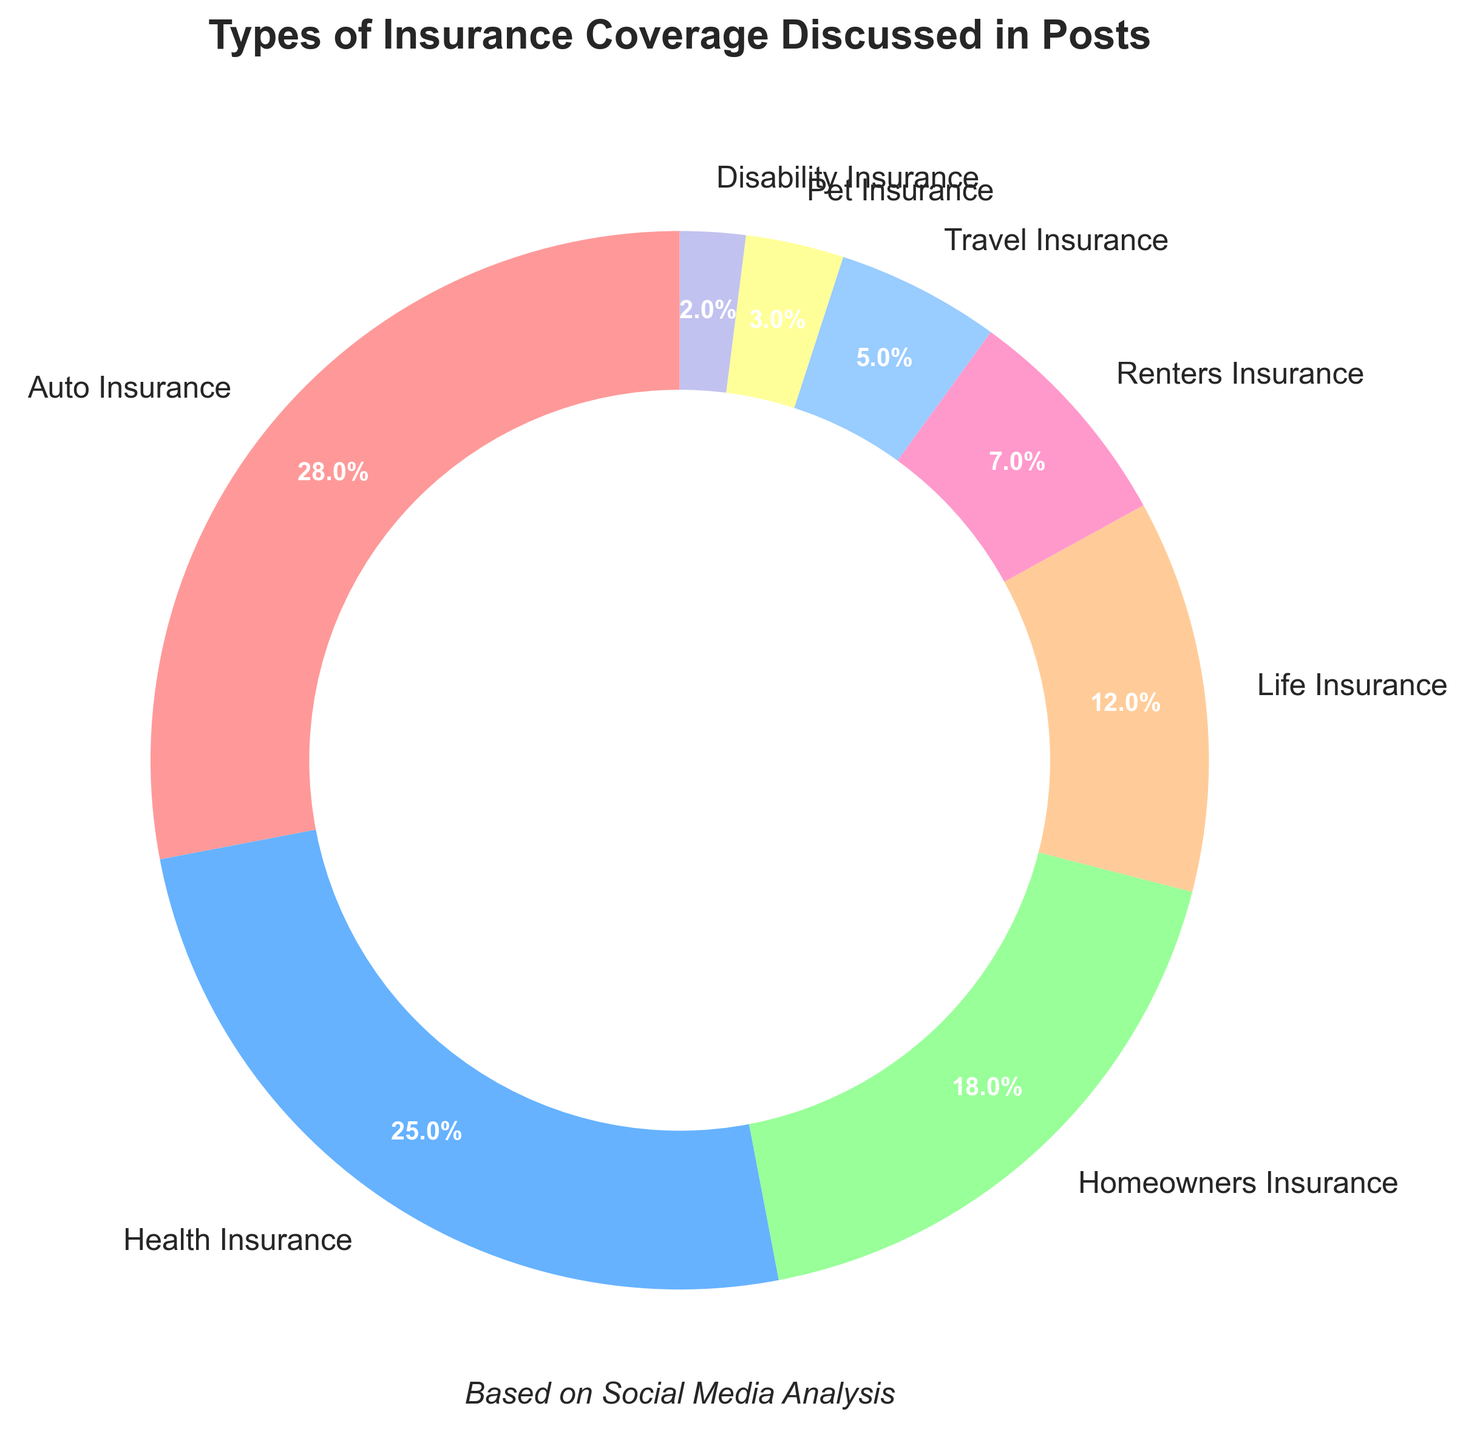What percentage of posts discuss Auto Insurance and Health Insurance combined? Add the percentage of Auto Insurance (28%) to the percentage of Health Insurance (25%). The combined percentage is 28% + 25% = 53%.
Answer: 53% Which type of insurance coverage is discussed the least frequently? Pet Insurance and Disability Insurance have the lowest percentages according to the chart, with Disability Insurance being the lowest at 2%.
Answer: Disability Insurance Are homeowners and renters combined more frequently discussed than life insurance alone? Add the percentages of homeowners (18%) and renters (7%) insurance and compare the sum to the percentage of life insurance (12%). The combined percentage is 18% + 7% = 25% which is greater than 12%.
Answer: Yes What is the difference in percentage between the most discussed insurance type and the least discussed insurance type? Subtract the percentage of Disability Insurance (2%) from the percentage of Auto Insurance (28%). The difference is 28% - 2% = 26%.
Answer: 26% Which types of insurance are discussed more frequently: Health and Homeowners Insurance combined, or Auto Insurance alone? Add the percentages of Health Insurance (25%) and Homeowners Insurance (18%) and compare to the percentage of Auto Insurance (28%). The combined percentage is 25% + 18% = 43%, which is greater than 28%.
Answer: Health and Homeowners Insurance combined By what percentage is Travel Insurance less frequently discussed than Homeowners Insurance? Subtract the percentage of Travel Insurance (5%) from the percentage of Homeowners Insurance (18%). The difference is 18% - 5% = 13%.
Answer: 13% How many types of insurance have a discussion frequency greater than or equal to 10%? Identify the types of insurance with percentages 10% or higher: Auto Insurance (28%), Health Insurance (25%), Homeowners Insurance (18%), and Life Insurance (12%). There are 4 types in total.
Answer: 4 Which type of insurance has a higher discussion frequency: Renters or Travel? Compare the percentages for Renters Insurance (7%) and Travel Insurance (5%). Renters Insurance has a higher frequency.
Answer: Renters Insurance What is the average discussion frequency of Auto, Health, and Life Insurance? Add the percentages of Auto (28%), Health (25%), and Life (12%) Insurance and divide by 3. The sum is 28% + 25% + 12% = 65%, so the average is 65% / 3 ≈ 21.67%.
Answer: 21.67% Which two insurance types together make up 33% of the discussions? Identify the pair of percentages that sum to 33%: Homeowners Insurance (18%) and Renters Insurance (7%) sum up to 18% + 7% = 25%; Homeowners Insurance (18%) and Travel Insurance (5%) sum up to 18% + 5% = 23%; Health Insurance (25%) and Disability Insurance (2%) sum up to 25% + 2% = 27%; Auto Insurance (28%) and Pet Insurance (3%) sum up to 28% + 3% = 31%; Auto Insurance (28%) and Disability Insurance (2%) sum up to 28% + 2% = 30%; Auto Insurance (28%) and Travel Insurance (5%) sum up to 28% + 5% = 33%.
Answer: Auto Insurance and Travel Insurance 